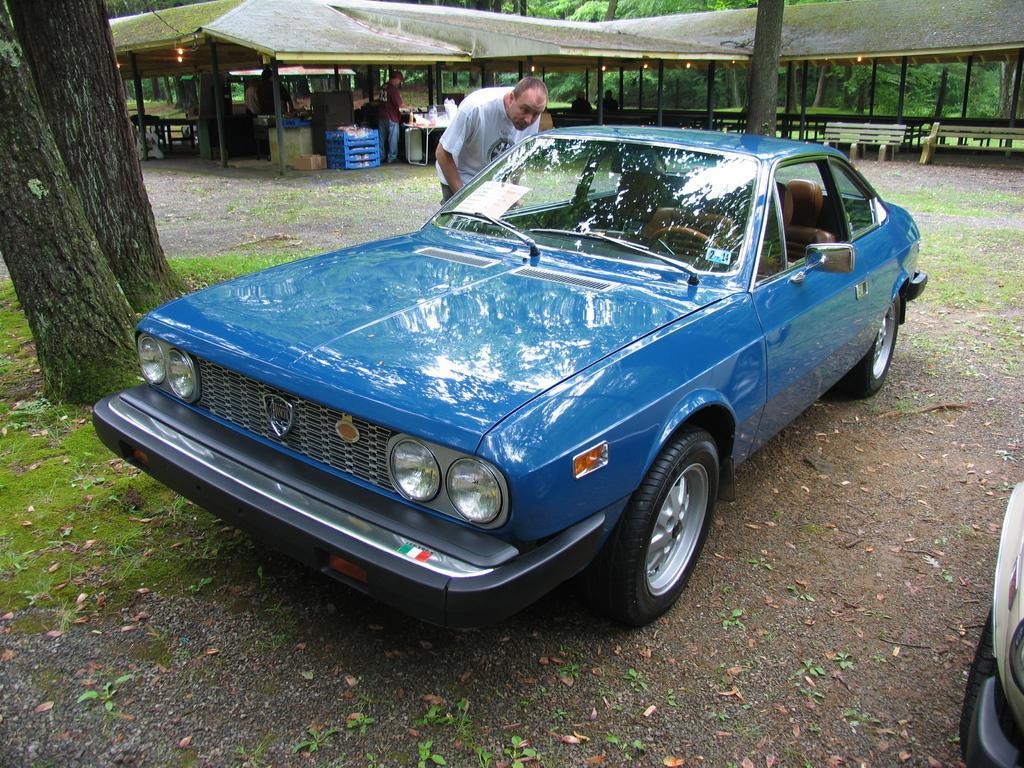Describe this image in one or two sentences. In this image we can see some persons standing on the ground. Two vehicles parked on the ground. In the background, we can see a shed with poles, bench, table with some objects, two persons are sitting, containers on the ground, a group of trees and some lights 